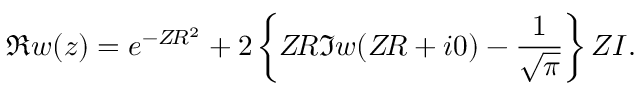<formula> <loc_0><loc_0><loc_500><loc_500>\Re w ( z ) = e ^ { - Z \, R ^ { 2 } } + 2 \left \{ Z \, R \Im w ( Z \, R + i 0 ) - \frac { 1 } { \sqrt { \pi } } \right \} Z I .</formula> 